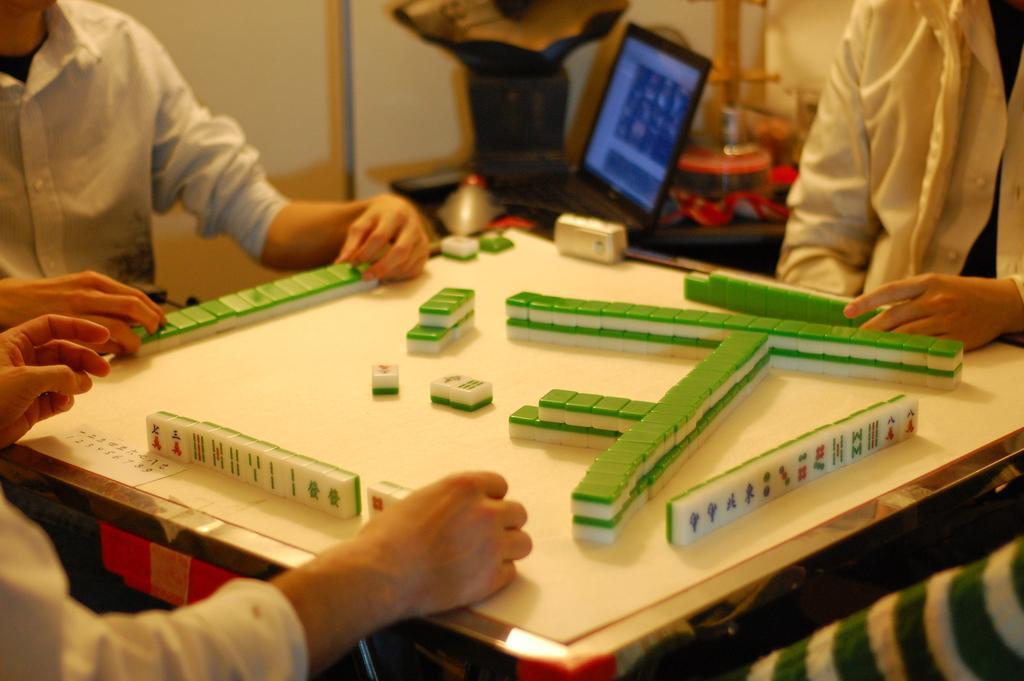Describe this image in one or two sentences. In this image we can see four people sitting and playing a board game where we can see a board game in the middle. In the background, we can see there is a laptop and some other objects on the surface and we can see a wall. 